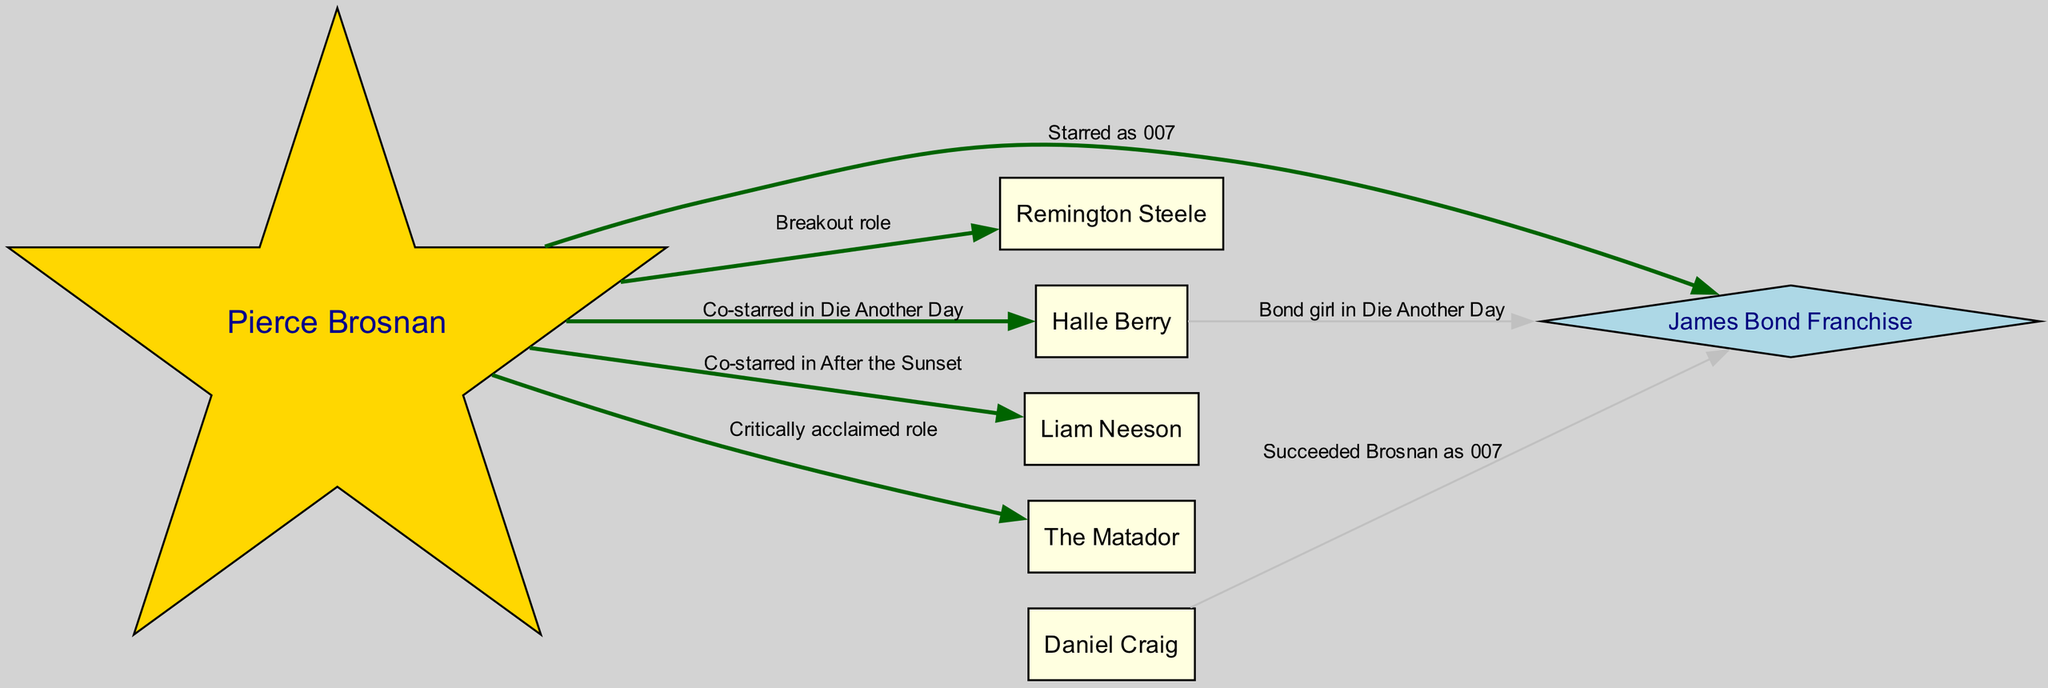What is the primary role of Pierce Brosnan in the diagram? The diagram indicates that Pierce Brosnan starred as James Bond, which is his most recognized role within the Hollywood connections.
Answer: Starred as 007 How many total nodes are present in the diagram? There are a total of 7 nodes representing Pierce Brosnan and his connections to other characters and films in the diagram.
Answer: 7 Who co-starred with Pierce Brosnan in "Die Another Day"? According to the diagram, Halle Berry is the individual who co-starred with Pierce Brosnan in "Die Another Day".
Answer: Halle Berry What role did Daniel Craig have in relation to Pierce Brosnan? The diagram shows that Daniel Craig succeeded Pierce Brosnan as James Bond, indicating a transition of the role from Brosnan to Craig.
Answer: Succeeded Brosnan as 007 Which film is linked to Pierce Brosnan with the label "Critically acclaimed role"? The diagram indicates that "The Matador" is the film associated with the label "Critically acclaimed role" for Pierce Brosnan.
Answer: The Matador What type of role did Pierce Brosnan play in "Remington Steele"? The diagram describes "Remington Steele" as Pierce Brosnan's breakout role, indicating its significance in his career.
Answer: Breakout role Which connection indicates a co-star relationship with Liam Neeson? The diagram reflects that Pierce Brosnan co-starred with Liam Neeson in the film "After the Sunset", indicating their shared cinematic experience.
Answer: Co-starred in After the Sunset How does Halle Berry connect to the James Bond franchise in the diagram? The diagram shows that Halle Berry is a Bond girl in "Die Another Day", which connects her to the James Bond franchise through her role in that film.
Answer: Bond girl in Die Another Day 